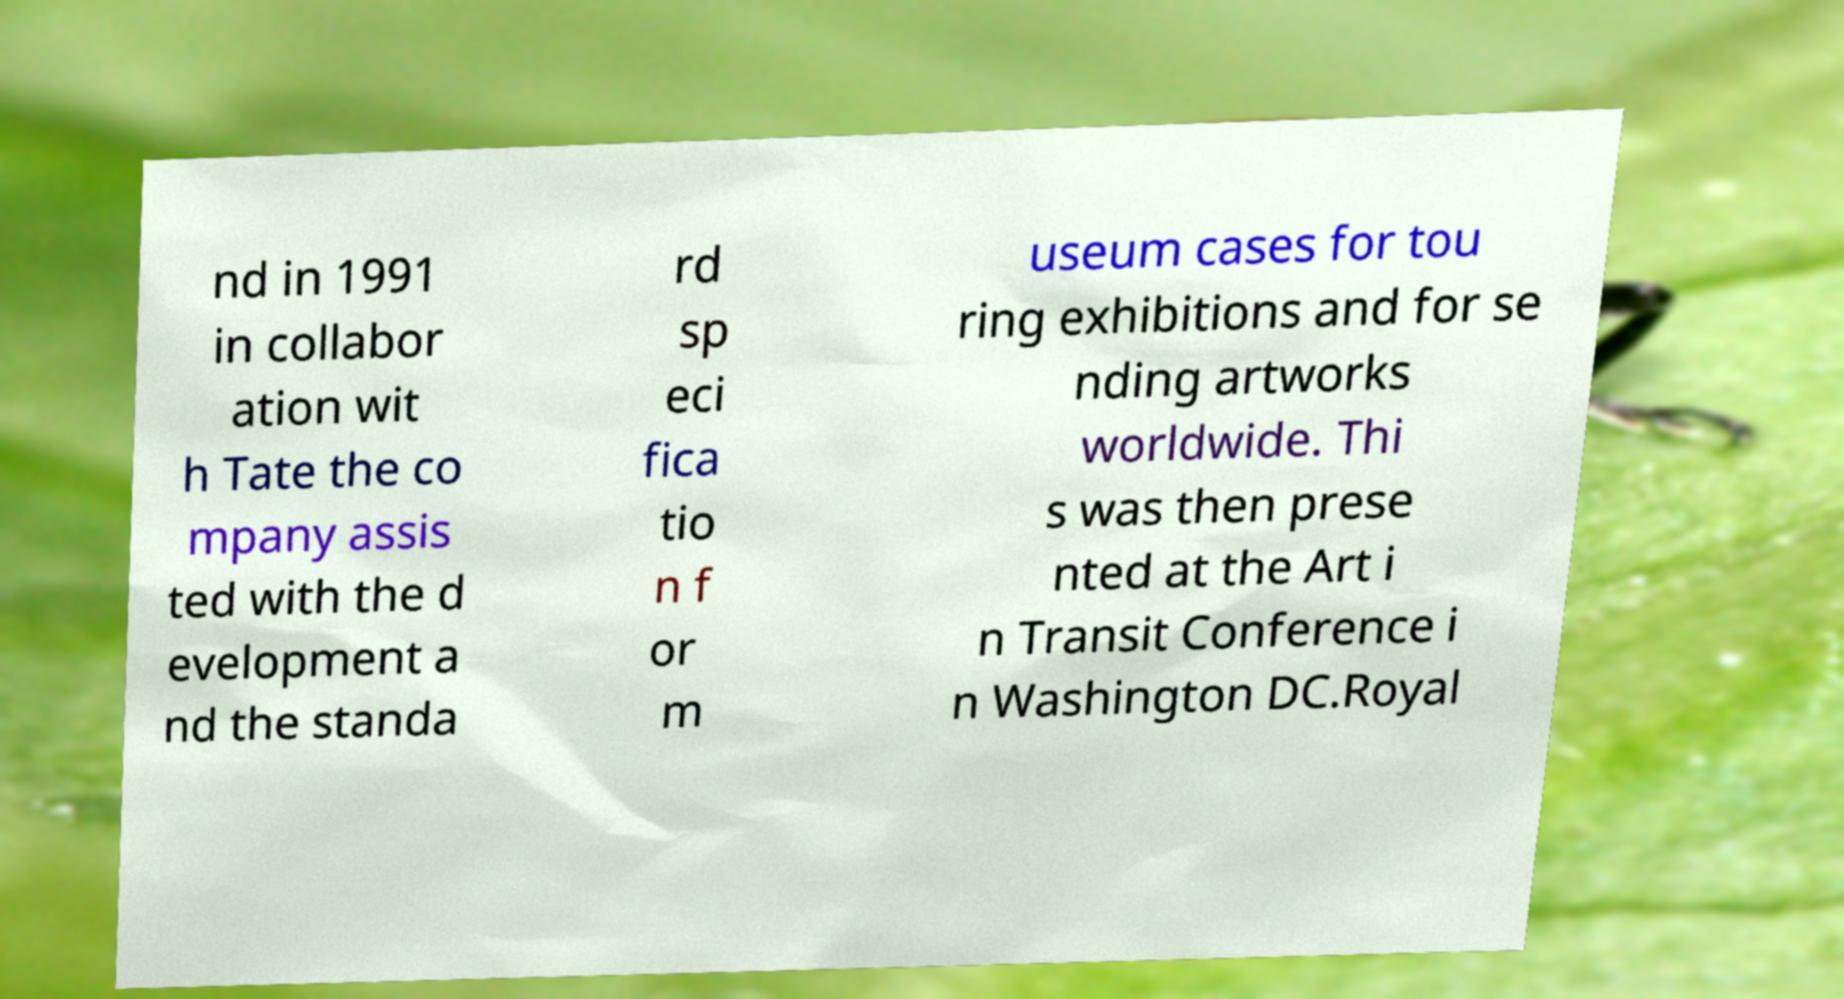Could you extract and type out the text from this image? nd in 1991 in collabor ation wit h Tate the co mpany assis ted with the d evelopment a nd the standa rd sp eci fica tio n f or m useum cases for tou ring exhibitions and for se nding artworks worldwide. Thi s was then prese nted at the Art i n Transit Conference i n Washington DC.Royal 